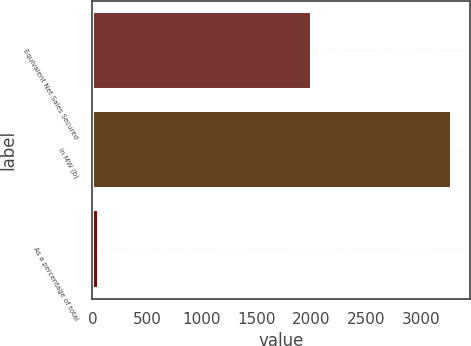Convert chart. <chart><loc_0><loc_0><loc_500><loc_500><bar_chart><fcel>Equivalent Net Sales Secured<fcel>In MW (b)<fcel>As a percentage of total<nl><fcel>2008<fcel>3283<fcel>57<nl></chart> 